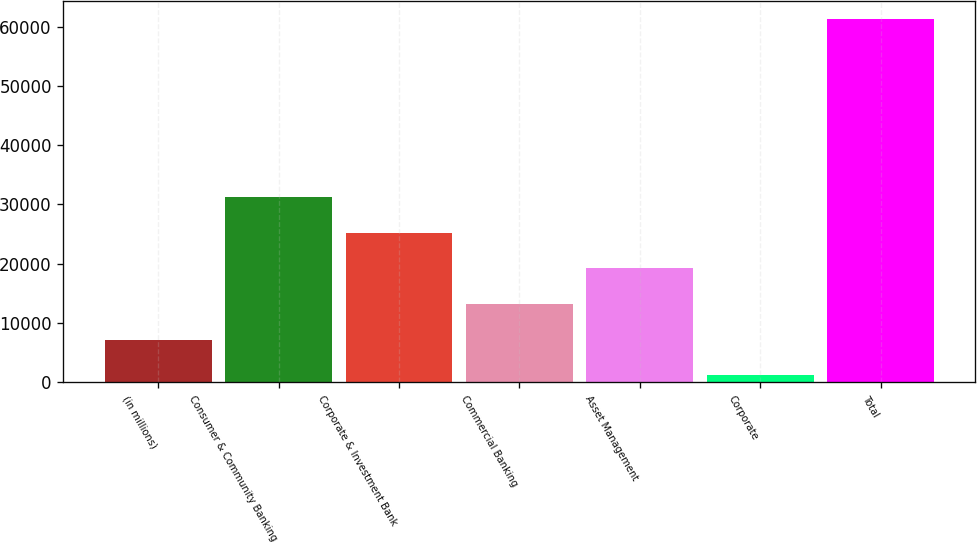Convert chart to OTSL. <chart><loc_0><loc_0><loc_500><loc_500><bar_chart><fcel>(in millions)<fcel>Consumer & Community Banking<fcel>Corporate & Investment Bank<fcel>Commercial Banking<fcel>Asset Management<fcel>Corporate<fcel>Total<nl><fcel>7170.5<fcel>31216.5<fcel>25205<fcel>13182<fcel>19193.5<fcel>1159<fcel>61274<nl></chart> 